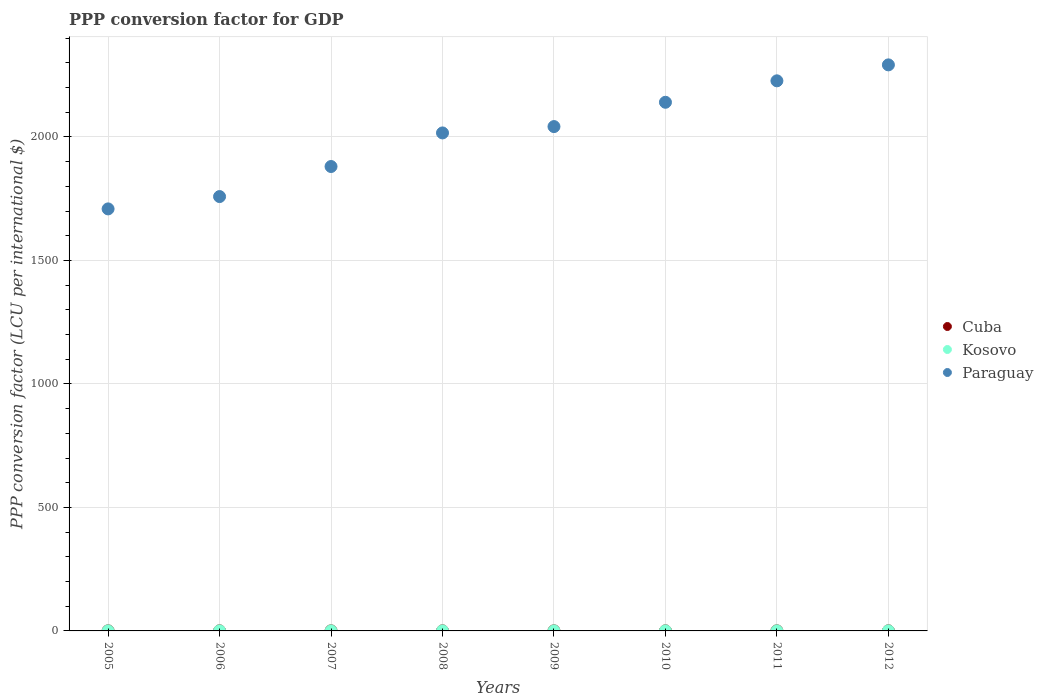How many different coloured dotlines are there?
Provide a short and direct response. 3. What is the PPP conversion factor for GDP in Paraguay in 2011?
Offer a terse response. 2227.34. Across all years, what is the maximum PPP conversion factor for GDP in Cuba?
Provide a short and direct response. 0.33. Across all years, what is the minimum PPP conversion factor for GDP in Cuba?
Ensure brevity in your answer.  0.3. What is the total PPP conversion factor for GDP in Kosovo in the graph?
Your response must be concise. 2.47. What is the difference between the PPP conversion factor for GDP in Kosovo in 2006 and that in 2008?
Provide a short and direct response. -0.01. What is the difference between the PPP conversion factor for GDP in Cuba in 2007 and the PPP conversion factor for GDP in Kosovo in 2010?
Provide a succinct answer. 0. What is the average PPP conversion factor for GDP in Paraguay per year?
Offer a very short reply. 2008.26. In the year 2009, what is the difference between the PPP conversion factor for GDP in Cuba and PPP conversion factor for GDP in Kosovo?
Offer a very short reply. 0.01. What is the ratio of the PPP conversion factor for GDP in Kosovo in 2011 to that in 2012?
Ensure brevity in your answer.  1. Is the difference between the PPP conversion factor for GDP in Cuba in 2007 and 2009 greater than the difference between the PPP conversion factor for GDP in Kosovo in 2007 and 2009?
Provide a short and direct response. Yes. What is the difference between the highest and the second highest PPP conversion factor for GDP in Kosovo?
Make the answer very short. 0. What is the difference between the highest and the lowest PPP conversion factor for GDP in Kosovo?
Ensure brevity in your answer.  0.04. In how many years, is the PPP conversion factor for GDP in Cuba greater than the average PPP conversion factor for GDP in Cuba taken over all years?
Give a very brief answer. 4. Is the sum of the PPP conversion factor for GDP in Paraguay in 2006 and 2007 greater than the maximum PPP conversion factor for GDP in Cuba across all years?
Your answer should be compact. Yes. Does the PPP conversion factor for GDP in Paraguay monotonically increase over the years?
Provide a succinct answer. Yes. How many years are there in the graph?
Your answer should be compact. 8. What is the difference between two consecutive major ticks on the Y-axis?
Offer a terse response. 500. Are the values on the major ticks of Y-axis written in scientific E-notation?
Offer a very short reply. No. Does the graph contain any zero values?
Your answer should be compact. No. Does the graph contain grids?
Provide a succinct answer. Yes. How many legend labels are there?
Provide a succinct answer. 3. How are the legend labels stacked?
Your response must be concise. Vertical. What is the title of the graph?
Your answer should be compact. PPP conversion factor for GDP. What is the label or title of the Y-axis?
Your response must be concise. PPP conversion factor (LCU per international $). What is the PPP conversion factor (LCU per international $) of Cuba in 2005?
Offer a very short reply. 0.3. What is the PPP conversion factor (LCU per international $) in Kosovo in 2005?
Ensure brevity in your answer.  0.29. What is the PPP conversion factor (LCU per international $) in Paraguay in 2005?
Keep it short and to the point. 1708.78. What is the PPP conversion factor (LCU per international $) in Cuba in 2006?
Offer a very short reply. 0.32. What is the PPP conversion factor (LCU per international $) in Kosovo in 2006?
Your response must be concise. 0.3. What is the PPP conversion factor (LCU per international $) of Paraguay in 2006?
Give a very brief answer. 1758.68. What is the PPP conversion factor (LCU per international $) of Cuba in 2007?
Your answer should be compact. 0.32. What is the PPP conversion factor (LCU per international $) of Kosovo in 2007?
Offer a terse response. 0.29. What is the PPP conversion factor (LCU per international $) of Paraguay in 2007?
Your answer should be compact. 1880.39. What is the PPP conversion factor (LCU per international $) in Cuba in 2008?
Make the answer very short. 0.32. What is the PPP conversion factor (LCU per international $) of Kosovo in 2008?
Give a very brief answer. 0.31. What is the PPP conversion factor (LCU per international $) in Paraguay in 2008?
Your answer should be very brief. 2016.39. What is the PPP conversion factor (LCU per international $) in Cuba in 2009?
Your answer should be very brief. 0.32. What is the PPP conversion factor (LCU per international $) of Kosovo in 2009?
Offer a terse response. 0.31. What is the PPP conversion factor (LCU per international $) of Paraguay in 2009?
Your answer should be very brief. 2042.08. What is the PPP conversion factor (LCU per international $) in Cuba in 2010?
Make the answer very short. 0.31. What is the PPP conversion factor (LCU per international $) of Kosovo in 2010?
Keep it short and to the point. 0.32. What is the PPP conversion factor (LCU per international $) of Paraguay in 2010?
Your answer should be very brief. 2140.51. What is the PPP conversion factor (LCU per international $) in Cuba in 2011?
Give a very brief answer. 0.32. What is the PPP conversion factor (LCU per international $) in Kosovo in 2011?
Provide a short and direct response. 0.33. What is the PPP conversion factor (LCU per international $) in Paraguay in 2011?
Your answer should be very brief. 2227.34. What is the PPP conversion factor (LCU per international $) of Cuba in 2012?
Keep it short and to the point. 0.33. What is the PPP conversion factor (LCU per international $) of Kosovo in 2012?
Offer a very short reply. 0.33. What is the PPP conversion factor (LCU per international $) in Paraguay in 2012?
Provide a short and direct response. 2291.93. Across all years, what is the maximum PPP conversion factor (LCU per international $) of Cuba?
Provide a succinct answer. 0.33. Across all years, what is the maximum PPP conversion factor (LCU per international $) in Kosovo?
Make the answer very short. 0.33. Across all years, what is the maximum PPP conversion factor (LCU per international $) of Paraguay?
Offer a very short reply. 2291.93. Across all years, what is the minimum PPP conversion factor (LCU per international $) in Cuba?
Provide a succinct answer. 0.3. Across all years, what is the minimum PPP conversion factor (LCU per international $) of Kosovo?
Make the answer very short. 0.29. Across all years, what is the minimum PPP conversion factor (LCU per international $) of Paraguay?
Make the answer very short. 1708.78. What is the total PPP conversion factor (LCU per international $) of Cuba in the graph?
Offer a very short reply. 2.53. What is the total PPP conversion factor (LCU per international $) in Kosovo in the graph?
Your response must be concise. 2.47. What is the total PPP conversion factor (LCU per international $) in Paraguay in the graph?
Your answer should be compact. 1.61e+04. What is the difference between the PPP conversion factor (LCU per international $) of Cuba in 2005 and that in 2006?
Your answer should be compact. -0.02. What is the difference between the PPP conversion factor (LCU per international $) of Kosovo in 2005 and that in 2006?
Your response must be concise. -0. What is the difference between the PPP conversion factor (LCU per international $) of Paraguay in 2005 and that in 2006?
Ensure brevity in your answer.  -49.91. What is the difference between the PPP conversion factor (LCU per international $) in Cuba in 2005 and that in 2007?
Offer a very short reply. -0.02. What is the difference between the PPP conversion factor (LCU per international $) in Kosovo in 2005 and that in 2007?
Ensure brevity in your answer.  0. What is the difference between the PPP conversion factor (LCU per international $) of Paraguay in 2005 and that in 2007?
Your response must be concise. -171.62. What is the difference between the PPP conversion factor (LCU per international $) of Cuba in 2005 and that in 2008?
Keep it short and to the point. -0.02. What is the difference between the PPP conversion factor (LCU per international $) in Kosovo in 2005 and that in 2008?
Your answer should be very brief. -0.01. What is the difference between the PPP conversion factor (LCU per international $) of Paraguay in 2005 and that in 2008?
Your answer should be compact. -307.61. What is the difference between the PPP conversion factor (LCU per international $) in Cuba in 2005 and that in 2009?
Offer a very short reply. -0.02. What is the difference between the PPP conversion factor (LCU per international $) in Kosovo in 2005 and that in 2009?
Your answer should be very brief. -0.01. What is the difference between the PPP conversion factor (LCU per international $) of Paraguay in 2005 and that in 2009?
Ensure brevity in your answer.  -333.3. What is the difference between the PPP conversion factor (LCU per international $) of Cuba in 2005 and that in 2010?
Give a very brief answer. -0.02. What is the difference between the PPP conversion factor (LCU per international $) of Kosovo in 2005 and that in 2010?
Offer a very short reply. -0.02. What is the difference between the PPP conversion factor (LCU per international $) in Paraguay in 2005 and that in 2010?
Provide a succinct answer. -431.73. What is the difference between the PPP conversion factor (LCU per international $) in Cuba in 2005 and that in 2011?
Your answer should be very brief. -0.02. What is the difference between the PPP conversion factor (LCU per international $) of Kosovo in 2005 and that in 2011?
Make the answer very short. -0.03. What is the difference between the PPP conversion factor (LCU per international $) of Paraguay in 2005 and that in 2011?
Provide a succinct answer. -518.57. What is the difference between the PPP conversion factor (LCU per international $) in Cuba in 2005 and that in 2012?
Keep it short and to the point. -0.03. What is the difference between the PPP conversion factor (LCU per international $) in Kosovo in 2005 and that in 2012?
Provide a short and direct response. -0.03. What is the difference between the PPP conversion factor (LCU per international $) in Paraguay in 2005 and that in 2012?
Ensure brevity in your answer.  -583.16. What is the difference between the PPP conversion factor (LCU per international $) in Cuba in 2006 and that in 2007?
Your response must be concise. -0. What is the difference between the PPP conversion factor (LCU per international $) of Kosovo in 2006 and that in 2007?
Offer a very short reply. 0. What is the difference between the PPP conversion factor (LCU per international $) in Paraguay in 2006 and that in 2007?
Offer a very short reply. -121.71. What is the difference between the PPP conversion factor (LCU per international $) of Cuba in 2006 and that in 2008?
Keep it short and to the point. 0. What is the difference between the PPP conversion factor (LCU per international $) of Kosovo in 2006 and that in 2008?
Keep it short and to the point. -0.01. What is the difference between the PPP conversion factor (LCU per international $) in Paraguay in 2006 and that in 2008?
Your answer should be very brief. -257.7. What is the difference between the PPP conversion factor (LCU per international $) of Cuba in 2006 and that in 2009?
Provide a succinct answer. 0. What is the difference between the PPP conversion factor (LCU per international $) of Kosovo in 2006 and that in 2009?
Make the answer very short. -0.01. What is the difference between the PPP conversion factor (LCU per international $) of Paraguay in 2006 and that in 2009?
Your answer should be compact. -283.39. What is the difference between the PPP conversion factor (LCU per international $) of Cuba in 2006 and that in 2010?
Provide a short and direct response. 0. What is the difference between the PPP conversion factor (LCU per international $) in Kosovo in 2006 and that in 2010?
Offer a very short reply. -0.02. What is the difference between the PPP conversion factor (LCU per international $) of Paraguay in 2006 and that in 2010?
Offer a very short reply. -381.82. What is the difference between the PPP conversion factor (LCU per international $) of Cuba in 2006 and that in 2011?
Your answer should be very brief. -0. What is the difference between the PPP conversion factor (LCU per international $) of Kosovo in 2006 and that in 2011?
Provide a short and direct response. -0.03. What is the difference between the PPP conversion factor (LCU per international $) in Paraguay in 2006 and that in 2011?
Provide a short and direct response. -468.66. What is the difference between the PPP conversion factor (LCU per international $) in Cuba in 2006 and that in 2012?
Provide a succinct answer. -0.01. What is the difference between the PPP conversion factor (LCU per international $) of Kosovo in 2006 and that in 2012?
Make the answer very short. -0.03. What is the difference between the PPP conversion factor (LCU per international $) in Paraguay in 2006 and that in 2012?
Provide a short and direct response. -533.25. What is the difference between the PPP conversion factor (LCU per international $) in Cuba in 2007 and that in 2008?
Your response must be concise. 0.01. What is the difference between the PPP conversion factor (LCU per international $) in Kosovo in 2007 and that in 2008?
Provide a succinct answer. -0.01. What is the difference between the PPP conversion factor (LCU per international $) of Paraguay in 2007 and that in 2008?
Give a very brief answer. -135.99. What is the difference between the PPP conversion factor (LCU per international $) of Cuba in 2007 and that in 2009?
Give a very brief answer. 0.01. What is the difference between the PPP conversion factor (LCU per international $) in Kosovo in 2007 and that in 2009?
Provide a succinct answer. -0.02. What is the difference between the PPP conversion factor (LCU per international $) of Paraguay in 2007 and that in 2009?
Provide a short and direct response. -161.68. What is the difference between the PPP conversion factor (LCU per international $) of Cuba in 2007 and that in 2010?
Make the answer very short. 0.01. What is the difference between the PPP conversion factor (LCU per international $) in Kosovo in 2007 and that in 2010?
Ensure brevity in your answer.  -0.03. What is the difference between the PPP conversion factor (LCU per international $) in Paraguay in 2007 and that in 2010?
Give a very brief answer. -260.11. What is the difference between the PPP conversion factor (LCU per international $) in Cuba in 2007 and that in 2011?
Your response must be concise. 0. What is the difference between the PPP conversion factor (LCU per international $) in Kosovo in 2007 and that in 2011?
Offer a terse response. -0.04. What is the difference between the PPP conversion factor (LCU per international $) in Paraguay in 2007 and that in 2011?
Give a very brief answer. -346.95. What is the difference between the PPP conversion factor (LCU per international $) in Cuba in 2007 and that in 2012?
Provide a short and direct response. -0. What is the difference between the PPP conversion factor (LCU per international $) of Kosovo in 2007 and that in 2012?
Keep it short and to the point. -0.04. What is the difference between the PPP conversion factor (LCU per international $) of Paraguay in 2007 and that in 2012?
Offer a very short reply. -411.54. What is the difference between the PPP conversion factor (LCU per international $) in Cuba in 2008 and that in 2009?
Your response must be concise. 0. What is the difference between the PPP conversion factor (LCU per international $) of Kosovo in 2008 and that in 2009?
Your response must be concise. -0. What is the difference between the PPP conversion factor (LCU per international $) of Paraguay in 2008 and that in 2009?
Offer a very short reply. -25.69. What is the difference between the PPP conversion factor (LCU per international $) in Kosovo in 2008 and that in 2010?
Your answer should be very brief. -0.01. What is the difference between the PPP conversion factor (LCU per international $) of Paraguay in 2008 and that in 2010?
Your response must be concise. -124.12. What is the difference between the PPP conversion factor (LCU per international $) of Cuba in 2008 and that in 2011?
Make the answer very short. -0.01. What is the difference between the PPP conversion factor (LCU per international $) of Kosovo in 2008 and that in 2011?
Keep it short and to the point. -0.02. What is the difference between the PPP conversion factor (LCU per international $) in Paraguay in 2008 and that in 2011?
Provide a succinct answer. -210.95. What is the difference between the PPP conversion factor (LCU per international $) of Cuba in 2008 and that in 2012?
Provide a succinct answer. -0.01. What is the difference between the PPP conversion factor (LCU per international $) of Kosovo in 2008 and that in 2012?
Make the answer very short. -0.02. What is the difference between the PPP conversion factor (LCU per international $) of Paraguay in 2008 and that in 2012?
Provide a short and direct response. -275.55. What is the difference between the PPP conversion factor (LCU per international $) of Kosovo in 2009 and that in 2010?
Provide a short and direct response. -0.01. What is the difference between the PPP conversion factor (LCU per international $) of Paraguay in 2009 and that in 2010?
Your response must be concise. -98.43. What is the difference between the PPP conversion factor (LCU per international $) of Cuba in 2009 and that in 2011?
Your response must be concise. -0.01. What is the difference between the PPP conversion factor (LCU per international $) in Kosovo in 2009 and that in 2011?
Provide a short and direct response. -0.02. What is the difference between the PPP conversion factor (LCU per international $) of Paraguay in 2009 and that in 2011?
Ensure brevity in your answer.  -185.26. What is the difference between the PPP conversion factor (LCU per international $) in Cuba in 2009 and that in 2012?
Your response must be concise. -0.01. What is the difference between the PPP conversion factor (LCU per international $) of Kosovo in 2009 and that in 2012?
Offer a terse response. -0.02. What is the difference between the PPP conversion factor (LCU per international $) of Paraguay in 2009 and that in 2012?
Provide a succinct answer. -249.86. What is the difference between the PPP conversion factor (LCU per international $) of Cuba in 2010 and that in 2011?
Your response must be concise. -0.01. What is the difference between the PPP conversion factor (LCU per international $) in Kosovo in 2010 and that in 2011?
Make the answer very short. -0.01. What is the difference between the PPP conversion factor (LCU per international $) of Paraguay in 2010 and that in 2011?
Your response must be concise. -86.83. What is the difference between the PPP conversion factor (LCU per international $) in Cuba in 2010 and that in 2012?
Ensure brevity in your answer.  -0.01. What is the difference between the PPP conversion factor (LCU per international $) in Kosovo in 2010 and that in 2012?
Your answer should be compact. -0.01. What is the difference between the PPP conversion factor (LCU per international $) in Paraguay in 2010 and that in 2012?
Your response must be concise. -151.43. What is the difference between the PPP conversion factor (LCU per international $) in Cuba in 2011 and that in 2012?
Give a very brief answer. -0. What is the difference between the PPP conversion factor (LCU per international $) in Kosovo in 2011 and that in 2012?
Keep it short and to the point. -0. What is the difference between the PPP conversion factor (LCU per international $) in Paraguay in 2011 and that in 2012?
Offer a very short reply. -64.59. What is the difference between the PPP conversion factor (LCU per international $) of Cuba in 2005 and the PPP conversion factor (LCU per international $) of Kosovo in 2006?
Give a very brief answer. 0. What is the difference between the PPP conversion factor (LCU per international $) of Cuba in 2005 and the PPP conversion factor (LCU per international $) of Paraguay in 2006?
Offer a terse response. -1758.38. What is the difference between the PPP conversion factor (LCU per international $) of Kosovo in 2005 and the PPP conversion factor (LCU per international $) of Paraguay in 2006?
Give a very brief answer. -1758.39. What is the difference between the PPP conversion factor (LCU per international $) in Cuba in 2005 and the PPP conversion factor (LCU per international $) in Kosovo in 2007?
Keep it short and to the point. 0.01. What is the difference between the PPP conversion factor (LCU per international $) in Cuba in 2005 and the PPP conversion factor (LCU per international $) in Paraguay in 2007?
Keep it short and to the point. -1880.1. What is the difference between the PPP conversion factor (LCU per international $) in Kosovo in 2005 and the PPP conversion factor (LCU per international $) in Paraguay in 2007?
Give a very brief answer. -1880.1. What is the difference between the PPP conversion factor (LCU per international $) in Cuba in 2005 and the PPP conversion factor (LCU per international $) in Kosovo in 2008?
Ensure brevity in your answer.  -0.01. What is the difference between the PPP conversion factor (LCU per international $) of Cuba in 2005 and the PPP conversion factor (LCU per international $) of Paraguay in 2008?
Make the answer very short. -2016.09. What is the difference between the PPP conversion factor (LCU per international $) of Kosovo in 2005 and the PPP conversion factor (LCU per international $) of Paraguay in 2008?
Provide a succinct answer. -2016.09. What is the difference between the PPP conversion factor (LCU per international $) in Cuba in 2005 and the PPP conversion factor (LCU per international $) in Kosovo in 2009?
Your answer should be compact. -0.01. What is the difference between the PPP conversion factor (LCU per international $) of Cuba in 2005 and the PPP conversion factor (LCU per international $) of Paraguay in 2009?
Your answer should be very brief. -2041.78. What is the difference between the PPP conversion factor (LCU per international $) of Kosovo in 2005 and the PPP conversion factor (LCU per international $) of Paraguay in 2009?
Ensure brevity in your answer.  -2041.78. What is the difference between the PPP conversion factor (LCU per international $) in Cuba in 2005 and the PPP conversion factor (LCU per international $) in Kosovo in 2010?
Provide a short and direct response. -0.02. What is the difference between the PPP conversion factor (LCU per international $) in Cuba in 2005 and the PPP conversion factor (LCU per international $) in Paraguay in 2010?
Offer a terse response. -2140.21. What is the difference between the PPP conversion factor (LCU per international $) in Kosovo in 2005 and the PPP conversion factor (LCU per international $) in Paraguay in 2010?
Make the answer very short. -2140.21. What is the difference between the PPP conversion factor (LCU per international $) in Cuba in 2005 and the PPP conversion factor (LCU per international $) in Kosovo in 2011?
Provide a short and direct response. -0.03. What is the difference between the PPP conversion factor (LCU per international $) in Cuba in 2005 and the PPP conversion factor (LCU per international $) in Paraguay in 2011?
Make the answer very short. -2227.04. What is the difference between the PPP conversion factor (LCU per international $) in Kosovo in 2005 and the PPP conversion factor (LCU per international $) in Paraguay in 2011?
Keep it short and to the point. -2227.05. What is the difference between the PPP conversion factor (LCU per international $) of Cuba in 2005 and the PPP conversion factor (LCU per international $) of Kosovo in 2012?
Make the answer very short. -0.03. What is the difference between the PPP conversion factor (LCU per international $) of Cuba in 2005 and the PPP conversion factor (LCU per international $) of Paraguay in 2012?
Offer a terse response. -2291.64. What is the difference between the PPP conversion factor (LCU per international $) in Kosovo in 2005 and the PPP conversion factor (LCU per international $) in Paraguay in 2012?
Give a very brief answer. -2291.64. What is the difference between the PPP conversion factor (LCU per international $) of Cuba in 2006 and the PPP conversion factor (LCU per international $) of Kosovo in 2007?
Your answer should be compact. 0.03. What is the difference between the PPP conversion factor (LCU per international $) in Cuba in 2006 and the PPP conversion factor (LCU per international $) in Paraguay in 2007?
Your response must be concise. -1880.07. What is the difference between the PPP conversion factor (LCU per international $) in Kosovo in 2006 and the PPP conversion factor (LCU per international $) in Paraguay in 2007?
Give a very brief answer. -1880.1. What is the difference between the PPP conversion factor (LCU per international $) of Cuba in 2006 and the PPP conversion factor (LCU per international $) of Kosovo in 2008?
Your answer should be very brief. 0.01. What is the difference between the PPP conversion factor (LCU per international $) in Cuba in 2006 and the PPP conversion factor (LCU per international $) in Paraguay in 2008?
Your answer should be very brief. -2016.07. What is the difference between the PPP conversion factor (LCU per international $) of Kosovo in 2006 and the PPP conversion factor (LCU per international $) of Paraguay in 2008?
Give a very brief answer. -2016.09. What is the difference between the PPP conversion factor (LCU per international $) of Cuba in 2006 and the PPP conversion factor (LCU per international $) of Kosovo in 2009?
Offer a very short reply. 0.01. What is the difference between the PPP conversion factor (LCU per international $) in Cuba in 2006 and the PPP conversion factor (LCU per international $) in Paraguay in 2009?
Give a very brief answer. -2041.76. What is the difference between the PPP conversion factor (LCU per international $) in Kosovo in 2006 and the PPP conversion factor (LCU per international $) in Paraguay in 2009?
Provide a short and direct response. -2041.78. What is the difference between the PPP conversion factor (LCU per international $) of Cuba in 2006 and the PPP conversion factor (LCU per international $) of Kosovo in 2010?
Provide a succinct answer. 0. What is the difference between the PPP conversion factor (LCU per international $) of Cuba in 2006 and the PPP conversion factor (LCU per international $) of Paraguay in 2010?
Offer a very short reply. -2140.19. What is the difference between the PPP conversion factor (LCU per international $) in Kosovo in 2006 and the PPP conversion factor (LCU per international $) in Paraguay in 2010?
Ensure brevity in your answer.  -2140.21. What is the difference between the PPP conversion factor (LCU per international $) of Cuba in 2006 and the PPP conversion factor (LCU per international $) of Kosovo in 2011?
Provide a short and direct response. -0.01. What is the difference between the PPP conversion factor (LCU per international $) of Cuba in 2006 and the PPP conversion factor (LCU per international $) of Paraguay in 2011?
Provide a succinct answer. -2227.02. What is the difference between the PPP conversion factor (LCU per international $) in Kosovo in 2006 and the PPP conversion factor (LCU per international $) in Paraguay in 2011?
Your answer should be compact. -2227.04. What is the difference between the PPP conversion factor (LCU per international $) in Cuba in 2006 and the PPP conversion factor (LCU per international $) in Kosovo in 2012?
Your response must be concise. -0.01. What is the difference between the PPP conversion factor (LCU per international $) in Cuba in 2006 and the PPP conversion factor (LCU per international $) in Paraguay in 2012?
Offer a very short reply. -2291.61. What is the difference between the PPP conversion factor (LCU per international $) of Kosovo in 2006 and the PPP conversion factor (LCU per international $) of Paraguay in 2012?
Your response must be concise. -2291.64. What is the difference between the PPP conversion factor (LCU per international $) in Cuba in 2007 and the PPP conversion factor (LCU per international $) in Kosovo in 2008?
Keep it short and to the point. 0.02. What is the difference between the PPP conversion factor (LCU per international $) in Cuba in 2007 and the PPP conversion factor (LCU per international $) in Paraguay in 2008?
Offer a very short reply. -2016.07. What is the difference between the PPP conversion factor (LCU per international $) of Kosovo in 2007 and the PPP conversion factor (LCU per international $) of Paraguay in 2008?
Give a very brief answer. -2016.1. What is the difference between the PPP conversion factor (LCU per international $) in Cuba in 2007 and the PPP conversion factor (LCU per international $) in Kosovo in 2009?
Your response must be concise. 0.01. What is the difference between the PPP conversion factor (LCU per international $) in Cuba in 2007 and the PPP conversion factor (LCU per international $) in Paraguay in 2009?
Offer a very short reply. -2041.76. What is the difference between the PPP conversion factor (LCU per international $) of Kosovo in 2007 and the PPP conversion factor (LCU per international $) of Paraguay in 2009?
Provide a succinct answer. -2041.79. What is the difference between the PPP conversion factor (LCU per international $) of Cuba in 2007 and the PPP conversion factor (LCU per international $) of Kosovo in 2010?
Offer a terse response. 0. What is the difference between the PPP conversion factor (LCU per international $) in Cuba in 2007 and the PPP conversion factor (LCU per international $) in Paraguay in 2010?
Provide a short and direct response. -2140.18. What is the difference between the PPP conversion factor (LCU per international $) of Kosovo in 2007 and the PPP conversion factor (LCU per international $) of Paraguay in 2010?
Keep it short and to the point. -2140.22. What is the difference between the PPP conversion factor (LCU per international $) in Cuba in 2007 and the PPP conversion factor (LCU per international $) in Kosovo in 2011?
Provide a succinct answer. -0. What is the difference between the PPP conversion factor (LCU per international $) of Cuba in 2007 and the PPP conversion factor (LCU per international $) of Paraguay in 2011?
Give a very brief answer. -2227.02. What is the difference between the PPP conversion factor (LCU per international $) in Kosovo in 2007 and the PPP conversion factor (LCU per international $) in Paraguay in 2011?
Your answer should be compact. -2227.05. What is the difference between the PPP conversion factor (LCU per international $) of Cuba in 2007 and the PPP conversion factor (LCU per international $) of Kosovo in 2012?
Provide a short and direct response. -0.01. What is the difference between the PPP conversion factor (LCU per international $) of Cuba in 2007 and the PPP conversion factor (LCU per international $) of Paraguay in 2012?
Make the answer very short. -2291.61. What is the difference between the PPP conversion factor (LCU per international $) in Kosovo in 2007 and the PPP conversion factor (LCU per international $) in Paraguay in 2012?
Keep it short and to the point. -2291.64. What is the difference between the PPP conversion factor (LCU per international $) of Cuba in 2008 and the PPP conversion factor (LCU per international $) of Kosovo in 2009?
Your answer should be compact. 0.01. What is the difference between the PPP conversion factor (LCU per international $) in Cuba in 2008 and the PPP conversion factor (LCU per international $) in Paraguay in 2009?
Ensure brevity in your answer.  -2041.76. What is the difference between the PPP conversion factor (LCU per international $) of Kosovo in 2008 and the PPP conversion factor (LCU per international $) of Paraguay in 2009?
Provide a succinct answer. -2041.77. What is the difference between the PPP conversion factor (LCU per international $) in Cuba in 2008 and the PPP conversion factor (LCU per international $) in Kosovo in 2010?
Provide a short and direct response. -0. What is the difference between the PPP conversion factor (LCU per international $) of Cuba in 2008 and the PPP conversion factor (LCU per international $) of Paraguay in 2010?
Give a very brief answer. -2140.19. What is the difference between the PPP conversion factor (LCU per international $) of Kosovo in 2008 and the PPP conversion factor (LCU per international $) of Paraguay in 2010?
Your response must be concise. -2140.2. What is the difference between the PPP conversion factor (LCU per international $) in Cuba in 2008 and the PPP conversion factor (LCU per international $) in Kosovo in 2011?
Your answer should be very brief. -0.01. What is the difference between the PPP conversion factor (LCU per international $) of Cuba in 2008 and the PPP conversion factor (LCU per international $) of Paraguay in 2011?
Give a very brief answer. -2227.03. What is the difference between the PPP conversion factor (LCU per international $) of Kosovo in 2008 and the PPP conversion factor (LCU per international $) of Paraguay in 2011?
Provide a succinct answer. -2227.03. What is the difference between the PPP conversion factor (LCU per international $) of Cuba in 2008 and the PPP conversion factor (LCU per international $) of Kosovo in 2012?
Offer a terse response. -0.01. What is the difference between the PPP conversion factor (LCU per international $) of Cuba in 2008 and the PPP conversion factor (LCU per international $) of Paraguay in 2012?
Offer a terse response. -2291.62. What is the difference between the PPP conversion factor (LCU per international $) in Kosovo in 2008 and the PPP conversion factor (LCU per international $) in Paraguay in 2012?
Make the answer very short. -2291.63. What is the difference between the PPP conversion factor (LCU per international $) of Cuba in 2009 and the PPP conversion factor (LCU per international $) of Kosovo in 2010?
Offer a very short reply. -0. What is the difference between the PPP conversion factor (LCU per international $) of Cuba in 2009 and the PPP conversion factor (LCU per international $) of Paraguay in 2010?
Your answer should be compact. -2140.19. What is the difference between the PPP conversion factor (LCU per international $) in Kosovo in 2009 and the PPP conversion factor (LCU per international $) in Paraguay in 2010?
Offer a very short reply. -2140.2. What is the difference between the PPP conversion factor (LCU per international $) of Cuba in 2009 and the PPP conversion factor (LCU per international $) of Kosovo in 2011?
Ensure brevity in your answer.  -0.01. What is the difference between the PPP conversion factor (LCU per international $) of Cuba in 2009 and the PPP conversion factor (LCU per international $) of Paraguay in 2011?
Ensure brevity in your answer.  -2227.03. What is the difference between the PPP conversion factor (LCU per international $) of Kosovo in 2009 and the PPP conversion factor (LCU per international $) of Paraguay in 2011?
Make the answer very short. -2227.03. What is the difference between the PPP conversion factor (LCU per international $) of Cuba in 2009 and the PPP conversion factor (LCU per international $) of Kosovo in 2012?
Give a very brief answer. -0.01. What is the difference between the PPP conversion factor (LCU per international $) in Cuba in 2009 and the PPP conversion factor (LCU per international $) in Paraguay in 2012?
Keep it short and to the point. -2291.62. What is the difference between the PPP conversion factor (LCU per international $) in Kosovo in 2009 and the PPP conversion factor (LCU per international $) in Paraguay in 2012?
Ensure brevity in your answer.  -2291.63. What is the difference between the PPP conversion factor (LCU per international $) of Cuba in 2010 and the PPP conversion factor (LCU per international $) of Kosovo in 2011?
Offer a terse response. -0.01. What is the difference between the PPP conversion factor (LCU per international $) of Cuba in 2010 and the PPP conversion factor (LCU per international $) of Paraguay in 2011?
Offer a very short reply. -2227.03. What is the difference between the PPP conversion factor (LCU per international $) of Kosovo in 2010 and the PPP conversion factor (LCU per international $) of Paraguay in 2011?
Give a very brief answer. -2227.02. What is the difference between the PPP conversion factor (LCU per international $) in Cuba in 2010 and the PPP conversion factor (LCU per international $) in Kosovo in 2012?
Ensure brevity in your answer.  -0.01. What is the difference between the PPP conversion factor (LCU per international $) of Cuba in 2010 and the PPP conversion factor (LCU per international $) of Paraguay in 2012?
Give a very brief answer. -2291.62. What is the difference between the PPP conversion factor (LCU per international $) of Kosovo in 2010 and the PPP conversion factor (LCU per international $) of Paraguay in 2012?
Make the answer very short. -2291.62. What is the difference between the PPP conversion factor (LCU per international $) of Cuba in 2011 and the PPP conversion factor (LCU per international $) of Kosovo in 2012?
Give a very brief answer. -0.01. What is the difference between the PPP conversion factor (LCU per international $) in Cuba in 2011 and the PPP conversion factor (LCU per international $) in Paraguay in 2012?
Provide a short and direct response. -2291.61. What is the difference between the PPP conversion factor (LCU per international $) of Kosovo in 2011 and the PPP conversion factor (LCU per international $) of Paraguay in 2012?
Provide a succinct answer. -2291.61. What is the average PPP conversion factor (LCU per international $) in Cuba per year?
Provide a short and direct response. 0.32. What is the average PPP conversion factor (LCU per international $) in Kosovo per year?
Your answer should be very brief. 0.31. What is the average PPP conversion factor (LCU per international $) in Paraguay per year?
Give a very brief answer. 2008.26. In the year 2005, what is the difference between the PPP conversion factor (LCU per international $) in Cuba and PPP conversion factor (LCU per international $) in Kosovo?
Provide a short and direct response. 0. In the year 2005, what is the difference between the PPP conversion factor (LCU per international $) of Cuba and PPP conversion factor (LCU per international $) of Paraguay?
Make the answer very short. -1708.48. In the year 2005, what is the difference between the PPP conversion factor (LCU per international $) in Kosovo and PPP conversion factor (LCU per international $) in Paraguay?
Give a very brief answer. -1708.48. In the year 2006, what is the difference between the PPP conversion factor (LCU per international $) of Cuba and PPP conversion factor (LCU per international $) of Kosovo?
Offer a very short reply. 0.02. In the year 2006, what is the difference between the PPP conversion factor (LCU per international $) of Cuba and PPP conversion factor (LCU per international $) of Paraguay?
Provide a succinct answer. -1758.36. In the year 2006, what is the difference between the PPP conversion factor (LCU per international $) of Kosovo and PPP conversion factor (LCU per international $) of Paraguay?
Provide a short and direct response. -1758.39. In the year 2007, what is the difference between the PPP conversion factor (LCU per international $) in Cuba and PPP conversion factor (LCU per international $) in Kosovo?
Give a very brief answer. 0.03. In the year 2007, what is the difference between the PPP conversion factor (LCU per international $) of Cuba and PPP conversion factor (LCU per international $) of Paraguay?
Your response must be concise. -1880.07. In the year 2007, what is the difference between the PPP conversion factor (LCU per international $) in Kosovo and PPP conversion factor (LCU per international $) in Paraguay?
Your response must be concise. -1880.1. In the year 2008, what is the difference between the PPP conversion factor (LCU per international $) in Cuba and PPP conversion factor (LCU per international $) in Kosovo?
Ensure brevity in your answer.  0.01. In the year 2008, what is the difference between the PPP conversion factor (LCU per international $) of Cuba and PPP conversion factor (LCU per international $) of Paraguay?
Your answer should be very brief. -2016.07. In the year 2008, what is the difference between the PPP conversion factor (LCU per international $) in Kosovo and PPP conversion factor (LCU per international $) in Paraguay?
Ensure brevity in your answer.  -2016.08. In the year 2009, what is the difference between the PPP conversion factor (LCU per international $) in Cuba and PPP conversion factor (LCU per international $) in Kosovo?
Give a very brief answer. 0.01. In the year 2009, what is the difference between the PPP conversion factor (LCU per international $) in Cuba and PPP conversion factor (LCU per international $) in Paraguay?
Give a very brief answer. -2041.76. In the year 2009, what is the difference between the PPP conversion factor (LCU per international $) of Kosovo and PPP conversion factor (LCU per international $) of Paraguay?
Your response must be concise. -2041.77. In the year 2010, what is the difference between the PPP conversion factor (LCU per international $) of Cuba and PPP conversion factor (LCU per international $) of Kosovo?
Make the answer very short. -0. In the year 2010, what is the difference between the PPP conversion factor (LCU per international $) of Cuba and PPP conversion factor (LCU per international $) of Paraguay?
Your answer should be very brief. -2140.19. In the year 2010, what is the difference between the PPP conversion factor (LCU per international $) in Kosovo and PPP conversion factor (LCU per international $) in Paraguay?
Your response must be concise. -2140.19. In the year 2011, what is the difference between the PPP conversion factor (LCU per international $) of Cuba and PPP conversion factor (LCU per international $) of Kosovo?
Your answer should be compact. -0.01. In the year 2011, what is the difference between the PPP conversion factor (LCU per international $) of Cuba and PPP conversion factor (LCU per international $) of Paraguay?
Your response must be concise. -2227.02. In the year 2011, what is the difference between the PPP conversion factor (LCU per international $) of Kosovo and PPP conversion factor (LCU per international $) of Paraguay?
Provide a short and direct response. -2227.01. In the year 2012, what is the difference between the PPP conversion factor (LCU per international $) of Cuba and PPP conversion factor (LCU per international $) of Kosovo?
Offer a very short reply. -0. In the year 2012, what is the difference between the PPP conversion factor (LCU per international $) in Cuba and PPP conversion factor (LCU per international $) in Paraguay?
Provide a short and direct response. -2291.61. In the year 2012, what is the difference between the PPP conversion factor (LCU per international $) of Kosovo and PPP conversion factor (LCU per international $) of Paraguay?
Provide a short and direct response. -2291.61. What is the ratio of the PPP conversion factor (LCU per international $) in Cuba in 2005 to that in 2006?
Your answer should be compact. 0.93. What is the ratio of the PPP conversion factor (LCU per international $) in Paraguay in 2005 to that in 2006?
Your answer should be very brief. 0.97. What is the ratio of the PPP conversion factor (LCU per international $) in Cuba in 2005 to that in 2007?
Ensure brevity in your answer.  0.93. What is the ratio of the PPP conversion factor (LCU per international $) in Kosovo in 2005 to that in 2007?
Ensure brevity in your answer.  1.01. What is the ratio of the PPP conversion factor (LCU per international $) of Paraguay in 2005 to that in 2007?
Your answer should be compact. 0.91. What is the ratio of the PPP conversion factor (LCU per international $) of Cuba in 2005 to that in 2008?
Give a very brief answer. 0.95. What is the ratio of the PPP conversion factor (LCU per international $) in Kosovo in 2005 to that in 2008?
Your response must be concise. 0.96. What is the ratio of the PPP conversion factor (LCU per international $) in Paraguay in 2005 to that in 2008?
Keep it short and to the point. 0.85. What is the ratio of the PPP conversion factor (LCU per international $) in Cuba in 2005 to that in 2009?
Provide a short and direct response. 0.95. What is the ratio of the PPP conversion factor (LCU per international $) of Kosovo in 2005 to that in 2009?
Provide a succinct answer. 0.95. What is the ratio of the PPP conversion factor (LCU per international $) in Paraguay in 2005 to that in 2009?
Provide a succinct answer. 0.84. What is the ratio of the PPP conversion factor (LCU per international $) in Cuba in 2005 to that in 2010?
Offer a terse response. 0.95. What is the ratio of the PPP conversion factor (LCU per international $) in Kosovo in 2005 to that in 2010?
Offer a very short reply. 0.92. What is the ratio of the PPP conversion factor (LCU per international $) of Paraguay in 2005 to that in 2010?
Ensure brevity in your answer.  0.8. What is the ratio of the PPP conversion factor (LCU per international $) of Cuba in 2005 to that in 2011?
Offer a terse response. 0.93. What is the ratio of the PPP conversion factor (LCU per international $) in Kosovo in 2005 to that in 2011?
Ensure brevity in your answer.  0.9. What is the ratio of the PPP conversion factor (LCU per international $) of Paraguay in 2005 to that in 2011?
Your answer should be compact. 0.77. What is the ratio of the PPP conversion factor (LCU per international $) of Cuba in 2005 to that in 2012?
Offer a terse response. 0.92. What is the ratio of the PPP conversion factor (LCU per international $) in Kosovo in 2005 to that in 2012?
Provide a succinct answer. 0.9. What is the ratio of the PPP conversion factor (LCU per international $) in Paraguay in 2005 to that in 2012?
Give a very brief answer. 0.75. What is the ratio of the PPP conversion factor (LCU per international $) of Kosovo in 2006 to that in 2007?
Provide a succinct answer. 1.01. What is the ratio of the PPP conversion factor (LCU per international $) of Paraguay in 2006 to that in 2007?
Make the answer very short. 0.94. What is the ratio of the PPP conversion factor (LCU per international $) in Kosovo in 2006 to that in 2008?
Your response must be concise. 0.97. What is the ratio of the PPP conversion factor (LCU per international $) of Paraguay in 2006 to that in 2008?
Offer a very short reply. 0.87. What is the ratio of the PPP conversion factor (LCU per international $) in Cuba in 2006 to that in 2009?
Provide a short and direct response. 1.02. What is the ratio of the PPP conversion factor (LCU per international $) of Kosovo in 2006 to that in 2009?
Ensure brevity in your answer.  0.96. What is the ratio of the PPP conversion factor (LCU per international $) of Paraguay in 2006 to that in 2009?
Your answer should be compact. 0.86. What is the ratio of the PPP conversion factor (LCU per international $) in Cuba in 2006 to that in 2010?
Make the answer very short. 1.02. What is the ratio of the PPP conversion factor (LCU per international $) in Kosovo in 2006 to that in 2010?
Your answer should be compact. 0.93. What is the ratio of the PPP conversion factor (LCU per international $) in Paraguay in 2006 to that in 2010?
Your response must be concise. 0.82. What is the ratio of the PPP conversion factor (LCU per international $) of Kosovo in 2006 to that in 2011?
Keep it short and to the point. 0.9. What is the ratio of the PPP conversion factor (LCU per international $) in Paraguay in 2006 to that in 2011?
Keep it short and to the point. 0.79. What is the ratio of the PPP conversion factor (LCU per international $) in Cuba in 2006 to that in 2012?
Provide a short and direct response. 0.98. What is the ratio of the PPP conversion factor (LCU per international $) in Kosovo in 2006 to that in 2012?
Make the answer very short. 0.9. What is the ratio of the PPP conversion factor (LCU per international $) of Paraguay in 2006 to that in 2012?
Offer a terse response. 0.77. What is the ratio of the PPP conversion factor (LCU per international $) of Cuba in 2007 to that in 2008?
Provide a short and direct response. 1.02. What is the ratio of the PPP conversion factor (LCU per international $) in Kosovo in 2007 to that in 2008?
Offer a very short reply. 0.95. What is the ratio of the PPP conversion factor (LCU per international $) in Paraguay in 2007 to that in 2008?
Provide a short and direct response. 0.93. What is the ratio of the PPP conversion factor (LCU per international $) in Cuba in 2007 to that in 2009?
Make the answer very short. 1.02. What is the ratio of the PPP conversion factor (LCU per international $) in Kosovo in 2007 to that in 2009?
Give a very brief answer. 0.95. What is the ratio of the PPP conversion factor (LCU per international $) in Paraguay in 2007 to that in 2009?
Provide a succinct answer. 0.92. What is the ratio of the PPP conversion factor (LCU per international $) in Cuba in 2007 to that in 2010?
Keep it short and to the point. 1.02. What is the ratio of the PPP conversion factor (LCU per international $) in Kosovo in 2007 to that in 2010?
Provide a short and direct response. 0.91. What is the ratio of the PPP conversion factor (LCU per international $) in Paraguay in 2007 to that in 2010?
Keep it short and to the point. 0.88. What is the ratio of the PPP conversion factor (LCU per international $) in Cuba in 2007 to that in 2011?
Offer a terse response. 1. What is the ratio of the PPP conversion factor (LCU per international $) in Kosovo in 2007 to that in 2011?
Give a very brief answer. 0.89. What is the ratio of the PPP conversion factor (LCU per international $) in Paraguay in 2007 to that in 2011?
Ensure brevity in your answer.  0.84. What is the ratio of the PPP conversion factor (LCU per international $) in Cuba in 2007 to that in 2012?
Give a very brief answer. 0.99. What is the ratio of the PPP conversion factor (LCU per international $) of Kosovo in 2007 to that in 2012?
Keep it short and to the point. 0.89. What is the ratio of the PPP conversion factor (LCU per international $) of Paraguay in 2007 to that in 2012?
Make the answer very short. 0.82. What is the ratio of the PPP conversion factor (LCU per international $) in Kosovo in 2008 to that in 2009?
Your answer should be very brief. 0.99. What is the ratio of the PPP conversion factor (LCU per international $) in Paraguay in 2008 to that in 2009?
Offer a very short reply. 0.99. What is the ratio of the PPP conversion factor (LCU per international $) of Cuba in 2008 to that in 2010?
Give a very brief answer. 1. What is the ratio of the PPP conversion factor (LCU per international $) of Kosovo in 2008 to that in 2010?
Give a very brief answer. 0.96. What is the ratio of the PPP conversion factor (LCU per international $) of Paraguay in 2008 to that in 2010?
Your response must be concise. 0.94. What is the ratio of the PPP conversion factor (LCU per international $) of Cuba in 2008 to that in 2011?
Your response must be concise. 0.98. What is the ratio of the PPP conversion factor (LCU per international $) of Kosovo in 2008 to that in 2011?
Make the answer very short. 0.94. What is the ratio of the PPP conversion factor (LCU per international $) in Paraguay in 2008 to that in 2011?
Your answer should be very brief. 0.91. What is the ratio of the PPP conversion factor (LCU per international $) of Cuba in 2008 to that in 2012?
Make the answer very short. 0.97. What is the ratio of the PPP conversion factor (LCU per international $) in Kosovo in 2008 to that in 2012?
Your answer should be compact. 0.93. What is the ratio of the PPP conversion factor (LCU per international $) in Paraguay in 2008 to that in 2012?
Offer a very short reply. 0.88. What is the ratio of the PPP conversion factor (LCU per international $) of Cuba in 2009 to that in 2010?
Provide a short and direct response. 1. What is the ratio of the PPP conversion factor (LCU per international $) in Kosovo in 2009 to that in 2010?
Ensure brevity in your answer.  0.97. What is the ratio of the PPP conversion factor (LCU per international $) of Paraguay in 2009 to that in 2010?
Your answer should be compact. 0.95. What is the ratio of the PPP conversion factor (LCU per international $) of Cuba in 2009 to that in 2011?
Offer a very short reply. 0.98. What is the ratio of the PPP conversion factor (LCU per international $) in Kosovo in 2009 to that in 2011?
Give a very brief answer. 0.94. What is the ratio of the PPP conversion factor (LCU per international $) of Paraguay in 2009 to that in 2011?
Provide a succinct answer. 0.92. What is the ratio of the PPP conversion factor (LCU per international $) of Cuba in 2009 to that in 2012?
Offer a terse response. 0.97. What is the ratio of the PPP conversion factor (LCU per international $) in Paraguay in 2009 to that in 2012?
Offer a very short reply. 0.89. What is the ratio of the PPP conversion factor (LCU per international $) in Cuba in 2010 to that in 2011?
Your answer should be compact. 0.98. What is the ratio of the PPP conversion factor (LCU per international $) of Kosovo in 2010 to that in 2011?
Give a very brief answer. 0.98. What is the ratio of the PPP conversion factor (LCU per international $) in Paraguay in 2010 to that in 2011?
Keep it short and to the point. 0.96. What is the ratio of the PPP conversion factor (LCU per international $) of Kosovo in 2010 to that in 2012?
Ensure brevity in your answer.  0.97. What is the ratio of the PPP conversion factor (LCU per international $) in Paraguay in 2010 to that in 2012?
Keep it short and to the point. 0.93. What is the ratio of the PPP conversion factor (LCU per international $) of Kosovo in 2011 to that in 2012?
Your answer should be very brief. 1. What is the ratio of the PPP conversion factor (LCU per international $) in Paraguay in 2011 to that in 2012?
Provide a short and direct response. 0.97. What is the difference between the highest and the second highest PPP conversion factor (LCU per international $) in Cuba?
Your answer should be very brief. 0. What is the difference between the highest and the second highest PPP conversion factor (LCU per international $) in Kosovo?
Keep it short and to the point. 0. What is the difference between the highest and the second highest PPP conversion factor (LCU per international $) of Paraguay?
Ensure brevity in your answer.  64.59. What is the difference between the highest and the lowest PPP conversion factor (LCU per international $) in Cuba?
Offer a terse response. 0.03. What is the difference between the highest and the lowest PPP conversion factor (LCU per international $) of Kosovo?
Your answer should be very brief. 0.04. What is the difference between the highest and the lowest PPP conversion factor (LCU per international $) of Paraguay?
Give a very brief answer. 583.16. 